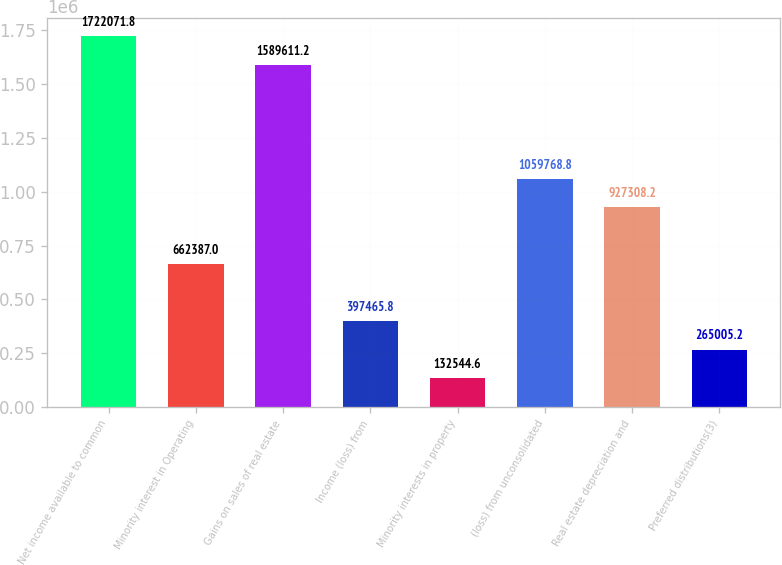Convert chart. <chart><loc_0><loc_0><loc_500><loc_500><bar_chart><fcel>Net income available to common<fcel>Minority interest in Operating<fcel>Gains on sales of real estate<fcel>Income (loss) from<fcel>Minority interests in property<fcel>(loss) from unconsolidated<fcel>Real estate depreciation and<fcel>Preferred distributions(3)<nl><fcel>1.72207e+06<fcel>662387<fcel>1.58961e+06<fcel>397466<fcel>132545<fcel>1.05977e+06<fcel>927308<fcel>265005<nl></chart> 